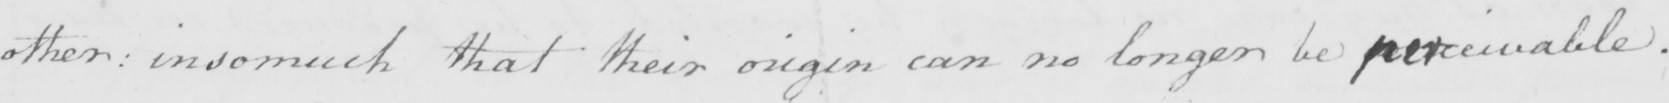Please provide the text content of this handwritten line. other :  insomuch that their origin can no longer be perceivable . 